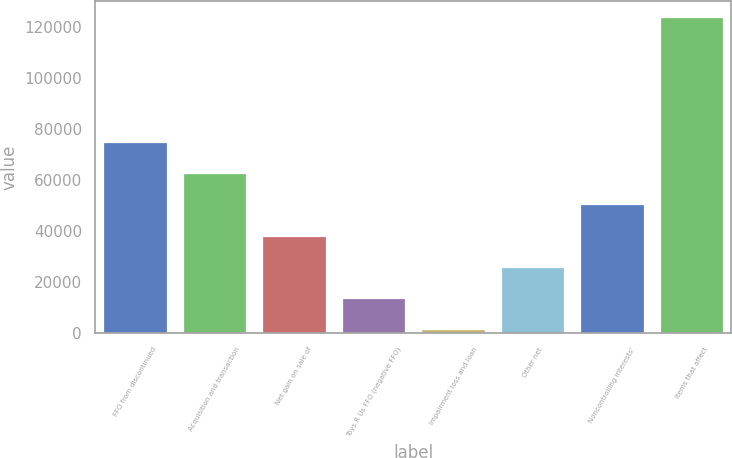Convert chart to OTSL. <chart><loc_0><loc_0><loc_500><loc_500><bar_chart><fcel>FFO from discontinued<fcel>Acquisition and transaction<fcel>Net gain on sale of<fcel>Toys R Us FFO (negative FFO)<fcel>Impairment loss and loan<fcel>Other net<fcel>Noncontrolling interests'<fcel>Items that affect<nl><fcel>74864.4<fcel>62645.5<fcel>38207.7<fcel>13769.9<fcel>1551<fcel>25988.8<fcel>50426.6<fcel>123740<nl></chart> 